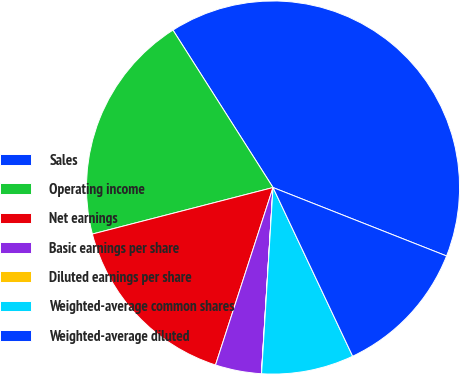Convert chart to OTSL. <chart><loc_0><loc_0><loc_500><loc_500><pie_chart><fcel>Sales<fcel>Operating income<fcel>Net earnings<fcel>Basic earnings per share<fcel>Diluted earnings per share<fcel>Weighted-average common shares<fcel>Weighted-average diluted<nl><fcel>39.99%<fcel>20.0%<fcel>16.0%<fcel>4.0%<fcel>0.01%<fcel>8.0%<fcel>12.0%<nl></chart> 